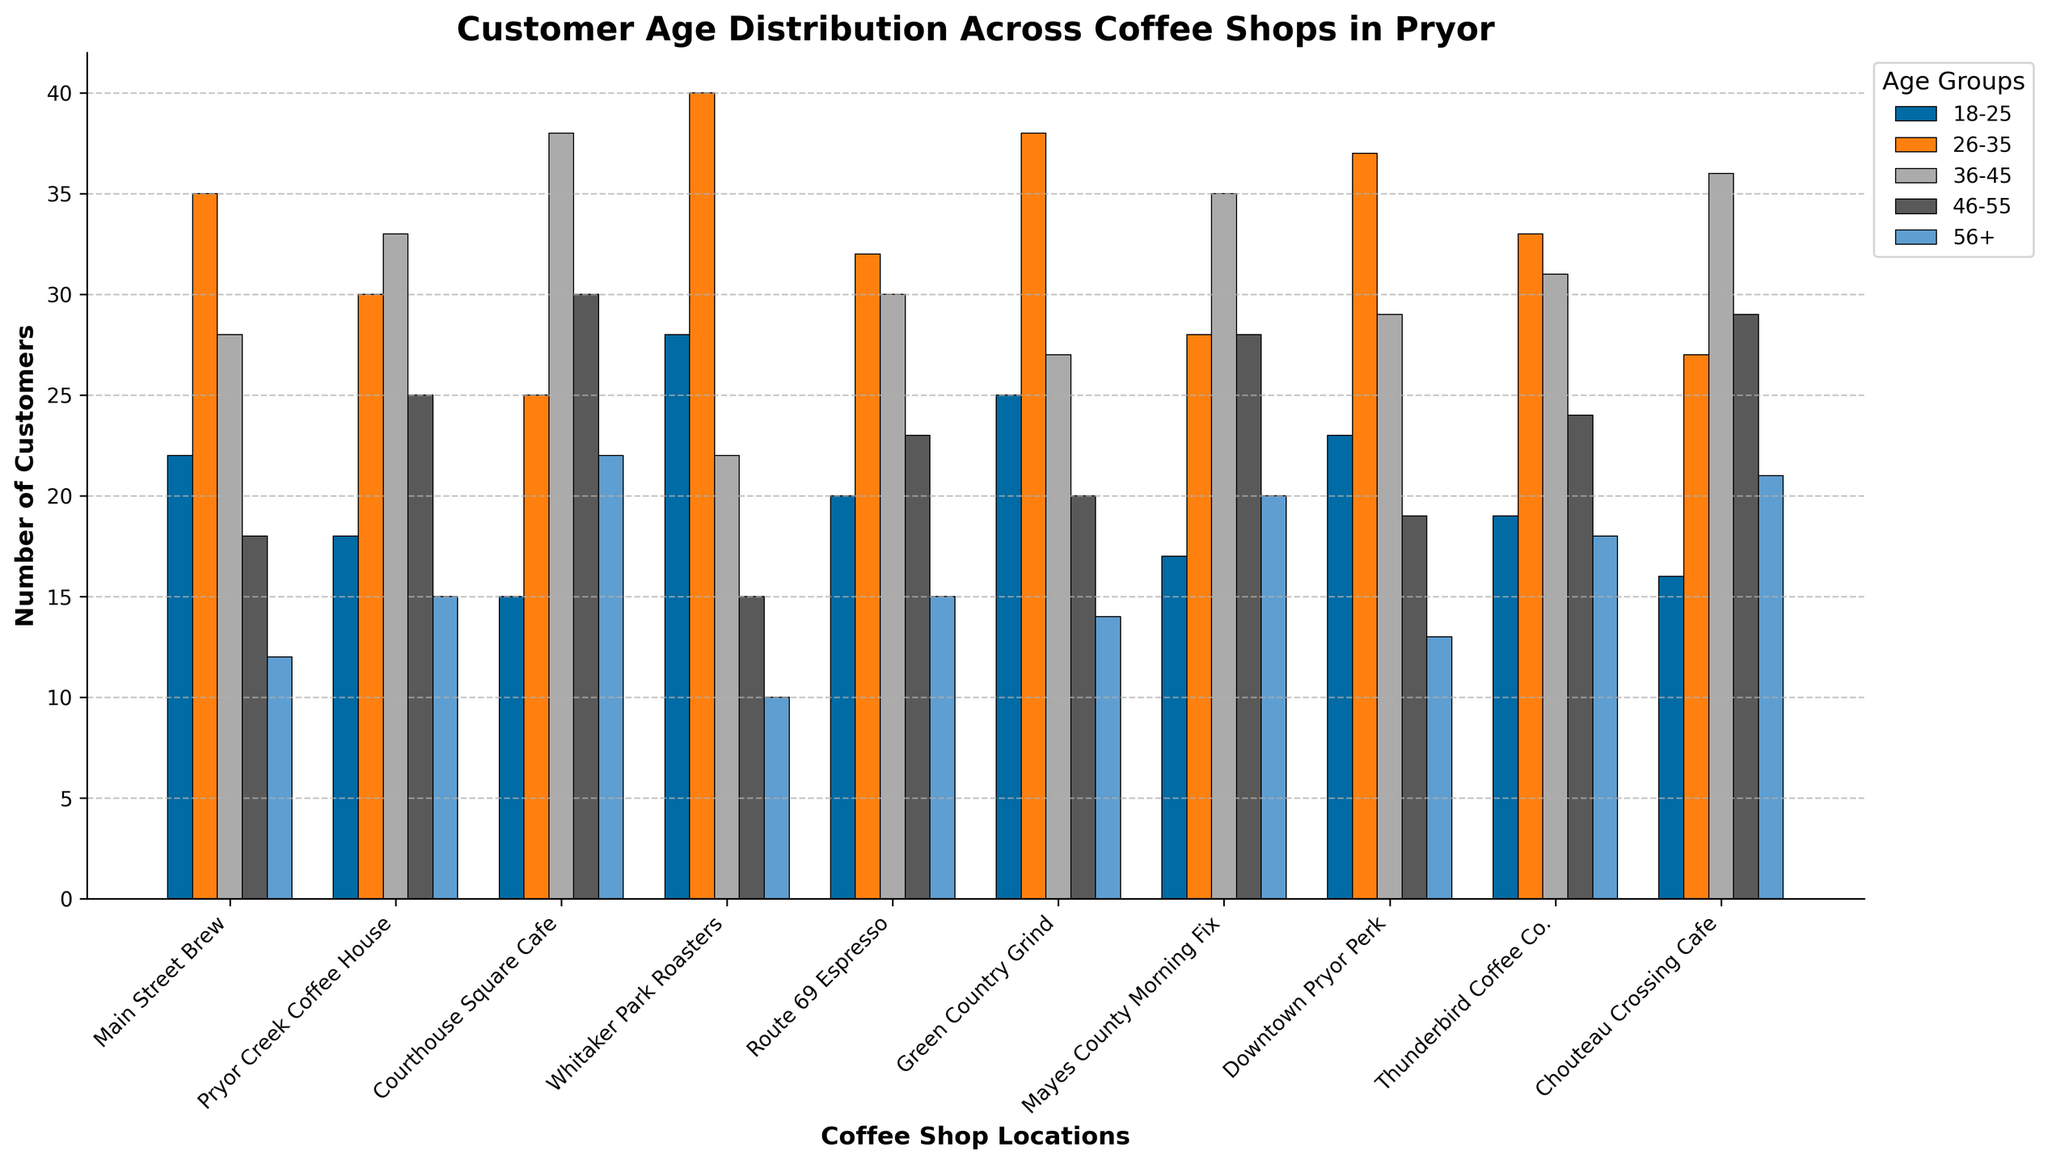Which location has the highest number of customers in the 26-35 age group? Look at the height of the bars for the 26-35 age group and identify the highest bar. Whitaker Park Roasters has the highest bar with 40 customers.
Answer: Whitaker Park Roasters Which age group has the most customers at Courthouse Square Cafe? Compare the height of the bars for each age group at Courthouse Square Cafe. The 36-45 age group has the tallest bar with 38 customers.
Answer: 36-45 How many total customers are there at Main Street Brew? Sum the values for all age groups at Main Street Brew: 22 (18-25) + 35 (26-35) + 28 (36-45) + 18 (46-55) + 12 (56+). Total is 115.
Answer: 115 Which location has the fewest customers in the 46-55 age group? Look at the height of the bars for the 46-55 age group and identify the shortest bar. Whitaker Park Roasters has the fewest customers with 15.
Answer: Whitaker Park Roasters What is the difference in the number of customers between the 18-25 and 56+ age groups at Downtown Pryor Perk? Identify the number of customers for each age group at Downtown Pryor Perk: 23 (18-25) and 13 (56+). Subtract 13 from 23 to get a difference of 10.
Answer: 10 Which age group has the highest average number of customers across all locations? Calculate the average for each age group: 
(22+18+15+28+20+25+17+23+19+16)/10 = 20.3 for 18-25 
(35+30+25+40+32+38+28+37+33+27)/10 = 32.5 for 26-35
(28+33+38+22+30+27+35+29+31+36)/10 = 30.9 for 36-45
(18+25+30+15+23+20+28+19+24+29)/10 = 23.1 for 46-55
(12+15+22+10+15+14+20+13+18+21)/10 = 16
The 26-35 age group has the highest average.
Answer: 26-35 At Thunder Bird Coffee Co., which two age groups have the closest number of customers? Compare the numbers for each age group at Thunderbird Coffee Co. 18-25 (19), 26-35 (33), 36-45 (31), 46-55 (24), 56+ (18). The two closest are 36-45 (31) and 26-35 (33) with a difference of 2.
Answer: 26-35 and 36-45 Which location attracts more younger customers (18-25 and 26-35 combined), Main Street Brew or Green Country Grind? Sum the customers for the 18-25 and 26-35 age groups for both locations: 
Main Street Brew: 22 (18-25) + 35 (26-35) = 57, 
Green Country Grind: 25 (18-25) + 38 (26-35) = 63. Green Country Grind attracts more younger customers.
Answer: Green Country Grind 